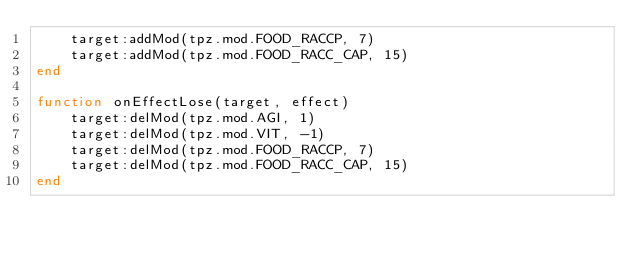<code> <loc_0><loc_0><loc_500><loc_500><_Lua_>    target:addMod(tpz.mod.FOOD_RACCP, 7)
    target:addMod(tpz.mod.FOOD_RACC_CAP, 15)
end

function onEffectLose(target, effect)
    target:delMod(tpz.mod.AGI, 1)
    target:delMod(tpz.mod.VIT, -1)
    target:delMod(tpz.mod.FOOD_RACCP, 7)
    target:delMod(tpz.mod.FOOD_RACC_CAP, 15)
end
</code> 